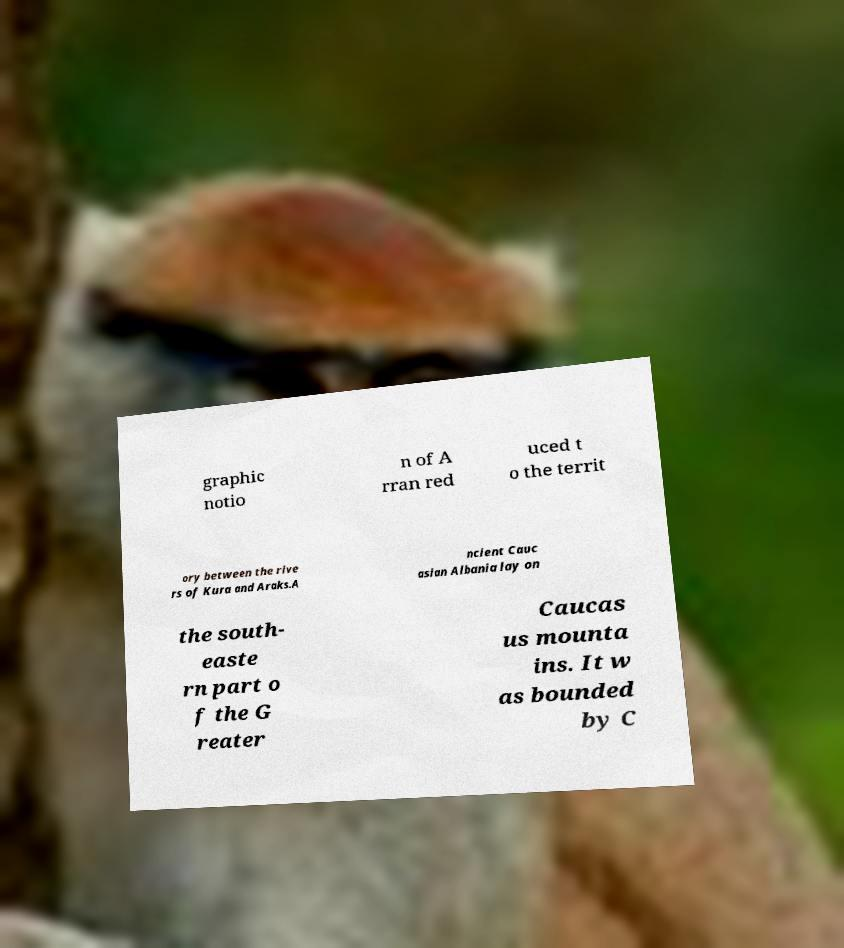Please read and relay the text visible in this image. What does it say? graphic notio n of A rran red uced t o the territ ory between the rive rs of Kura and Araks.A ncient Cauc asian Albania lay on the south- easte rn part o f the G reater Caucas us mounta ins. It w as bounded by C 